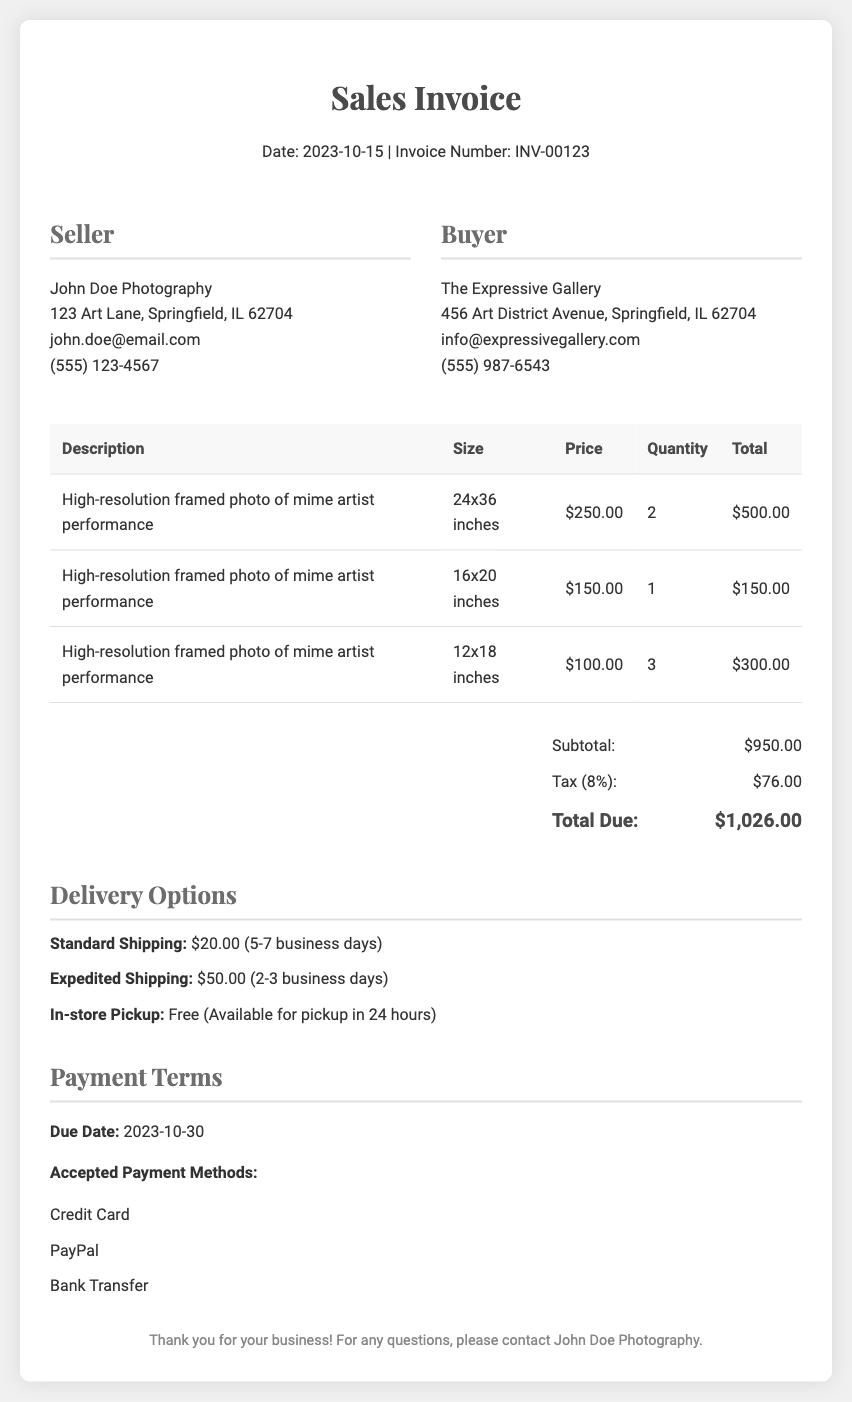What is the invoice number? The invoice number is indicated at the top of the document, which is a unique identifier for this sale.
Answer: INV-00123 What is the date of the invoice? The date is found within the header section of the document, indicating when the invoice is issued.
Answer: 2023-10-15 Who is the buyer? The buyer's information is detailed in the document, representing the entity purchasing the photos.
Answer: The Expressive Gallery What is the total due amount? The total due is calculated from the subtotal and tax, as indicated in the summary section of the invoice.
Answer: $1,026.00 How many photos were sold in 24x36 inches size? The quantity for this specific size is listed in the table of items sold.
Answer: 2 What is the price of the 16x20 inches photo? This price is specified in the price column for the respective size in the invoice.
Answer: $150.00 What is the subtotal amount? Subtotal represents the total cost before tax, found in the summary section.
Answer: $950.00 What are the available delivery options? The document lists various delivery methods available for shipping the purchased items.
Answer: Standard Shipping, Expedited Shipping, In-store Pickup What is the tax rate applied? The tax rate is mentioned in the summary of the invoice, providing clarity on added taxes.
Answer: 8% When is the payment due date? The payment due date is specified in the payment terms section, indicating when the payment must be made.
Answer: 2023-10-30 